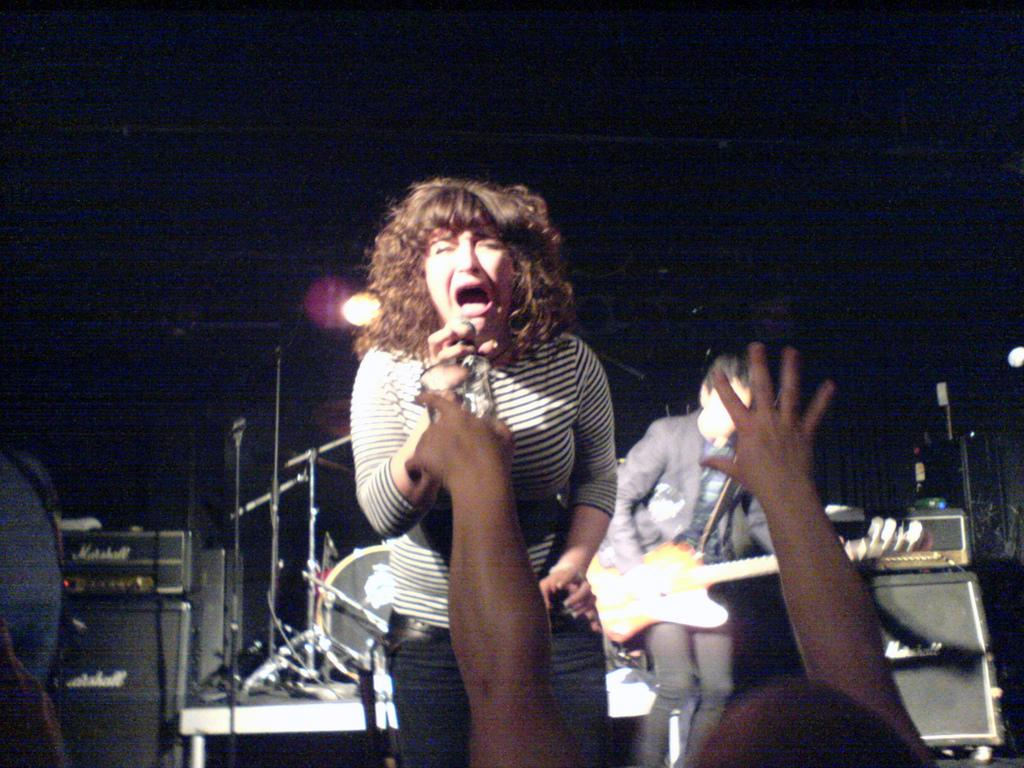How many people are in the image? There are people in the image, but the exact number is not specified. What can be seen in the background of the image? In the background of the image, there are musical instruments, devices, focusing lights, a stand, and a curtain. What is one person doing in the image? One person is playing a guitar. What type of punishment is being administered to the giants in the image? There are no giants present in the image, so there is no punishment being administered. What is the account balance of the person playing the guitar in the image? There is no information about the person's account balance in the image. 